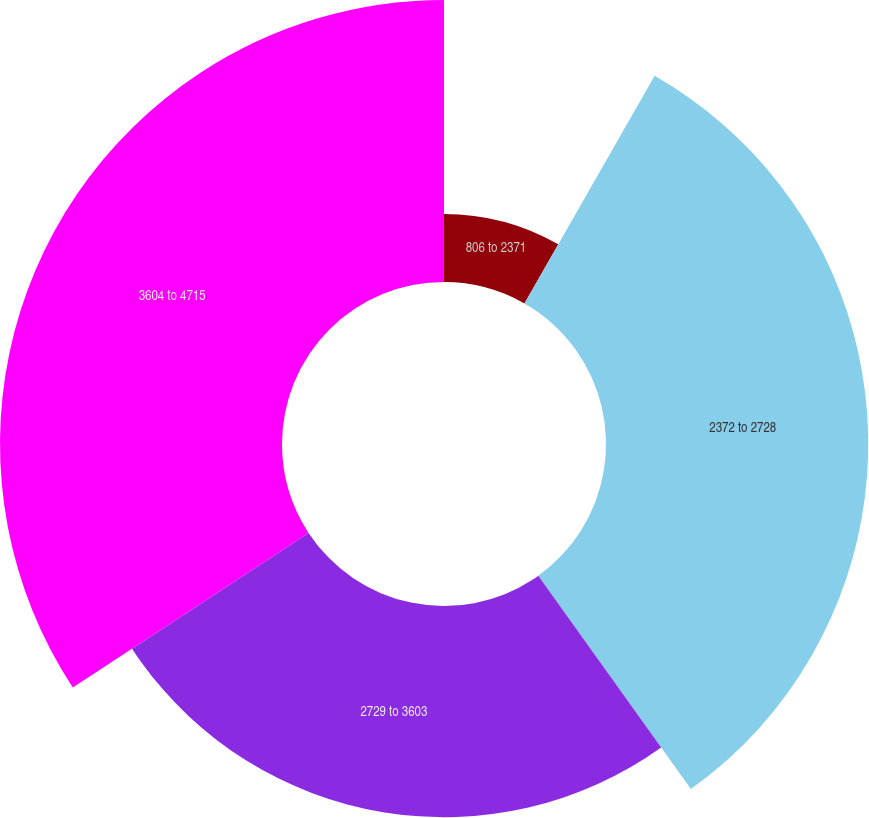<chart> <loc_0><loc_0><loc_500><loc_500><pie_chart><fcel>806 to 2371<fcel>2372 to 2728<fcel>2729 to 3603<fcel>3604 to 4715<nl><fcel>8.27%<fcel>31.84%<fcel>25.64%<fcel>34.24%<nl></chart> 